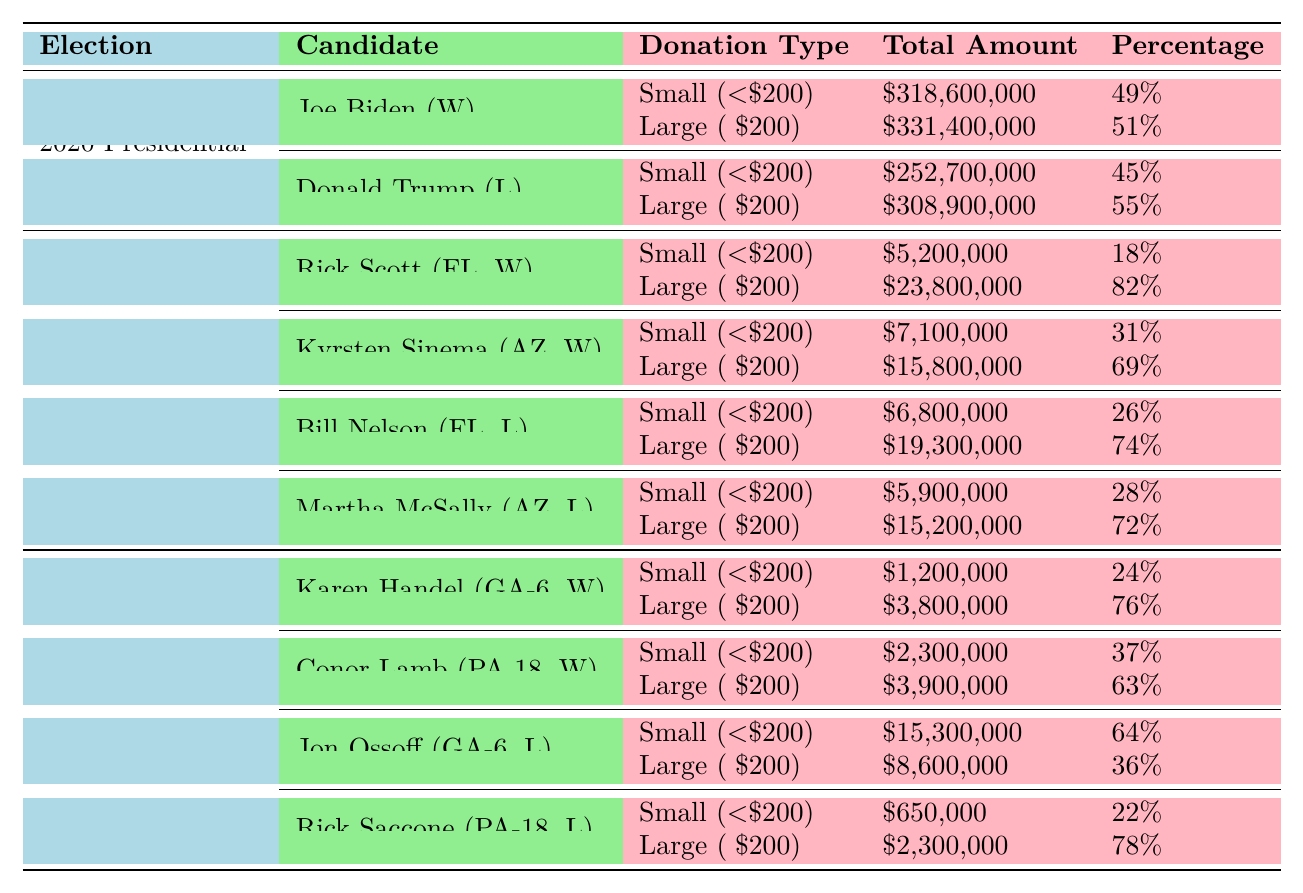What is the total amount of small-dollar donations for Joe Biden? According to the table, Joe Biden received a total of $318,600,000 in small-dollar donations.
Answer: $318,600,000 What percentage of total donations did Donald Trump receive from small-dollar donations? The table indicates that Donald Trump received 45% of his total donations from small-dollar contributions.
Answer: 45% Which candidate had a higher total amount of large-dollar donations: Rick Scott or Kyrsten Sinema? Rick Scott had $23,800,000 in large-dollar donations, while Kyrsten Sinema had $15,800,000. Comparing these amounts shows that Rick Scott had the higher total.
Answer: Rick Scott What is the difference in the number of small-dollar donors between Joe Biden and Donald Trump? Joe Biden had 6,980,000 small-dollar donors, and Donald Trump had 5,340,000. The difference is 6,980,000 - 5,340,000 = 1,640,000.
Answer: 1,640,000 Did the winning candidates in the 2016 House Races have a higher percentage of large-dollar donations than the losing candidates? For Karen Handel, the percentage of large-dollar donations was 76%, and for Conor Lamb, it was 63%. For Jon Ossoff, it was 36%, and for Rick Saccone, it was 78%. Both winning candidates had higher percentages than losing candidates, averaged out, the winning candidates had an average of 69.5% compared to 57%.
Answer: Yes What is the average amount of small-dollar donations received by winning candidates across all three elections? Joe Biden received $318,600,000, Rick Scott $5,200,000, Kyrsten Sinema $7,100,000, Karen Handel $1,200,000, and Conor Lamb $2,300,000. Summing these amounts gives $334,400,000, and dividing by 5 gives an average of $66,880,000.
Answer: $66,880,000 How many more donors did losing candidates have for small-dollar donations compared to winning candidates in the 2018 Senate Races? Bill Nelson had 145,000 donors, and Martha McSally had 126,000, totaling 271,000. Rick Scott had 98,000 and Kyrsten Sinema had 156,000, totaling 254,000. The difference is 271,000 - 254,000 = 17,000.
Answer: 17,000 Was the percentage of small-dollar donations for Jon Ossoff higher than 50%? Jon Ossoff had 64% of his total donations from small-dollar contributions, which is greater than 50%.
Answer: Yes What is the total amount of large-dollar donations received by losing candidates in the 2020 election? Donald Trump received $308,900,000 in large-dollar donations, which is the total amount from losing candidates in that election.
Answer: $308,900,000 How much did the losing candidates in the 2016 House Races receive in small-dollar donations compared to winning candidates? Jon Ossoff had $15,300,000 and Rick Saccone had $650,000 in small-dollar donations, totaling $15,950,000. Winning candidates received $1,200,000 and $2,300,000, totaling $3,500,000. The difference is $15,950,000 - $3,500,000 = $12,450,000.
Answer: $12,450,000 